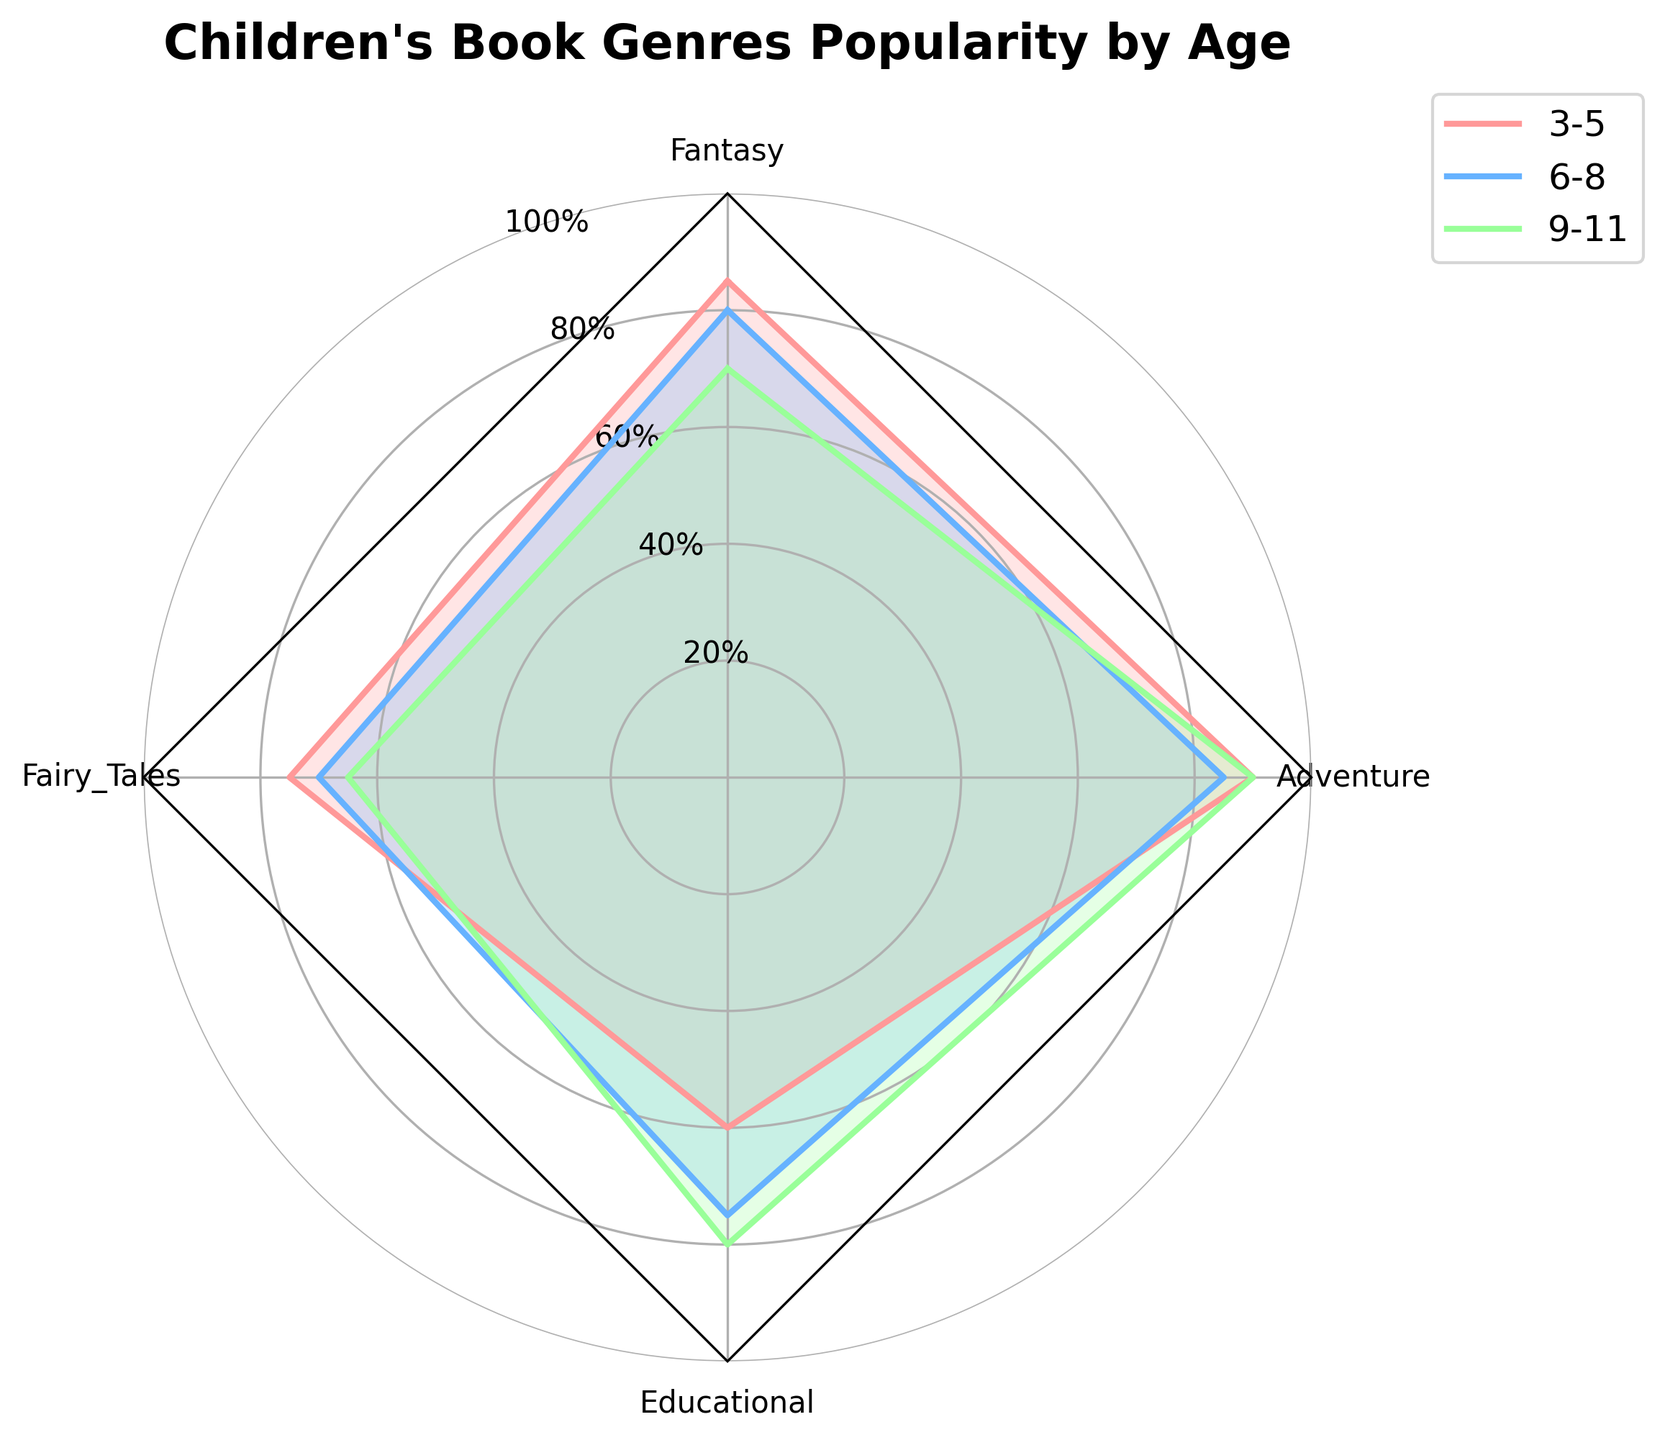What's the title of the chart? The title is found at the top of the figure. It is usually distinct and easy to spot. In this figure, it should be clearly labeled to describe the data.
Answer: Children's Book Genres Popularity by Age How many age groups are shown in the chart? The number of age groups can be counted by looking at the legend or the different colored lines on the radar chart.
Answer: 3 Which age group has the highest interest in Fantasy books? This can be determined by comparing the Fantasy values for each age group and finding the highest one. In the radar chart, each age group's Fantasy value is represented as a point along the corresponding axis.
Answer: 3-5 What is the average popularity of Educational books across all shown age groups? To find the average, add the popularity values for Educational books across the three age groups and divide by 3. (60 + 75 + 80) / 3 = 71.67.
Answer: 71.67 In which age group is the popularity of Adventure books equal to that of Fantasy books? Find the age group where the values for Adventure and Fantasy books are the same by comparing each group. The radar chart indicates similar lengths for both axes in that age group.
Answer: 3-5 Which book genre shows the least variation in popularity across the age groups? To determine this, observe the radar chart and identify which genre's values remain relatively steady between the different age groups.
Answer: Adventure How does the interest in Fairy Tales change from age group 3-5 to age group 9-11? Compare the Fairy Tales values for the age groups 3-5 and 9-11 to see the change. The value decreases from 75 to 65.
Answer: Decreases Which age group has the most balanced distribution of popularity across all genres? The most balanced distribution implies the least difference in popularity values for various genres within that age group. Compare the shapes of the lines representing each age group.
Answer: 12-14 What is the combined popularity of Fantasy and Adventure books for the age group 6-8? Add the values for Fantasy and Adventure for the age group 6-8. Fantasy (80) + Adventure (85) = 165.
Answer: 165 Is the popularity of Educational books higher than 70% for all shown age groups? Check the Educational book values for the three age groups to see if they are all above 70. One of the ages (3-5) has a value of 60, so the answer is no.
Answer: No 